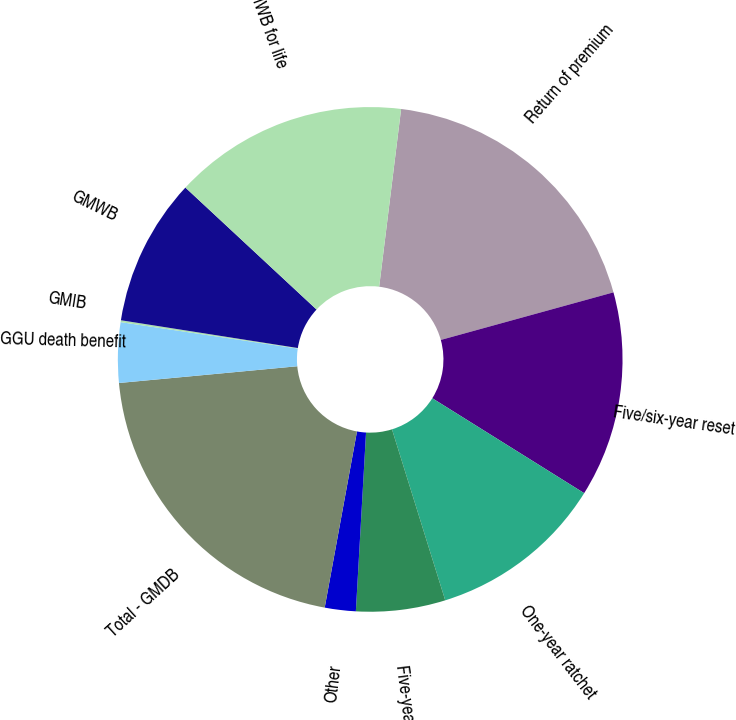Convert chart. <chart><loc_0><loc_0><loc_500><loc_500><pie_chart><fcel>Return of premium<fcel>Five/six-year reset<fcel>One-year ratchet<fcel>Five-year ratchet<fcel>Other<fcel>Total - GMDB<fcel>GGU death benefit<fcel>GMIB<fcel>GMWB<fcel>GMWB for life<nl><fcel>18.76%<fcel>13.17%<fcel>11.3%<fcel>5.71%<fcel>1.98%<fcel>20.62%<fcel>3.85%<fcel>0.12%<fcel>9.44%<fcel>15.03%<nl></chart> 